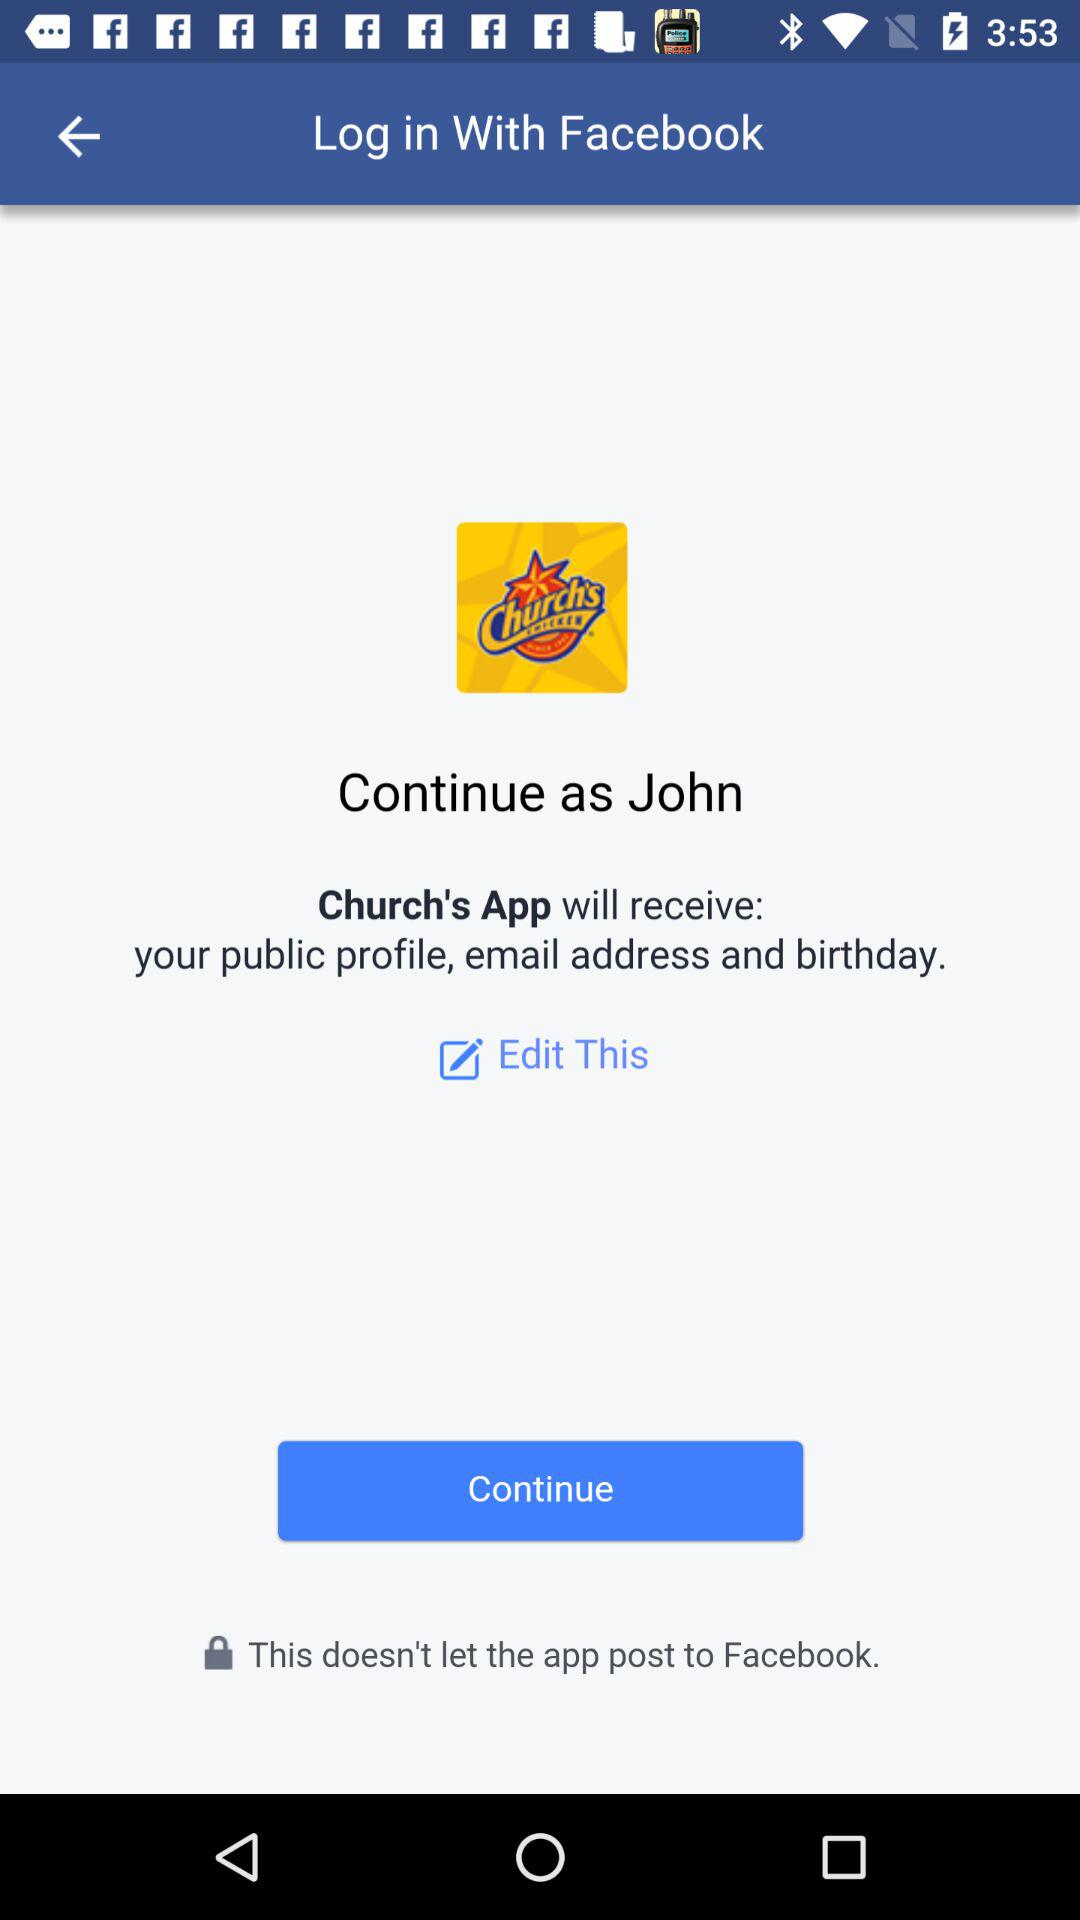What application is asking for permission? The application asking for permission is "Church's App". 